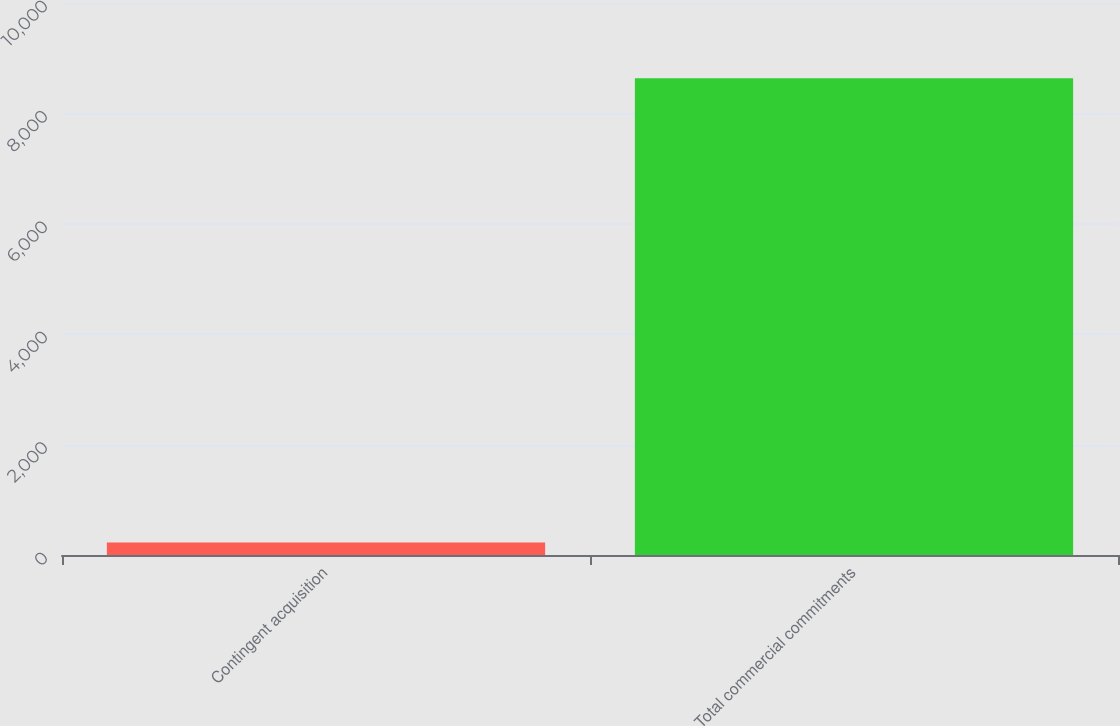Convert chart. <chart><loc_0><loc_0><loc_500><loc_500><bar_chart><fcel>Contingent acquisition<fcel>Total commercial commitments<nl><fcel>227<fcel>8638<nl></chart> 